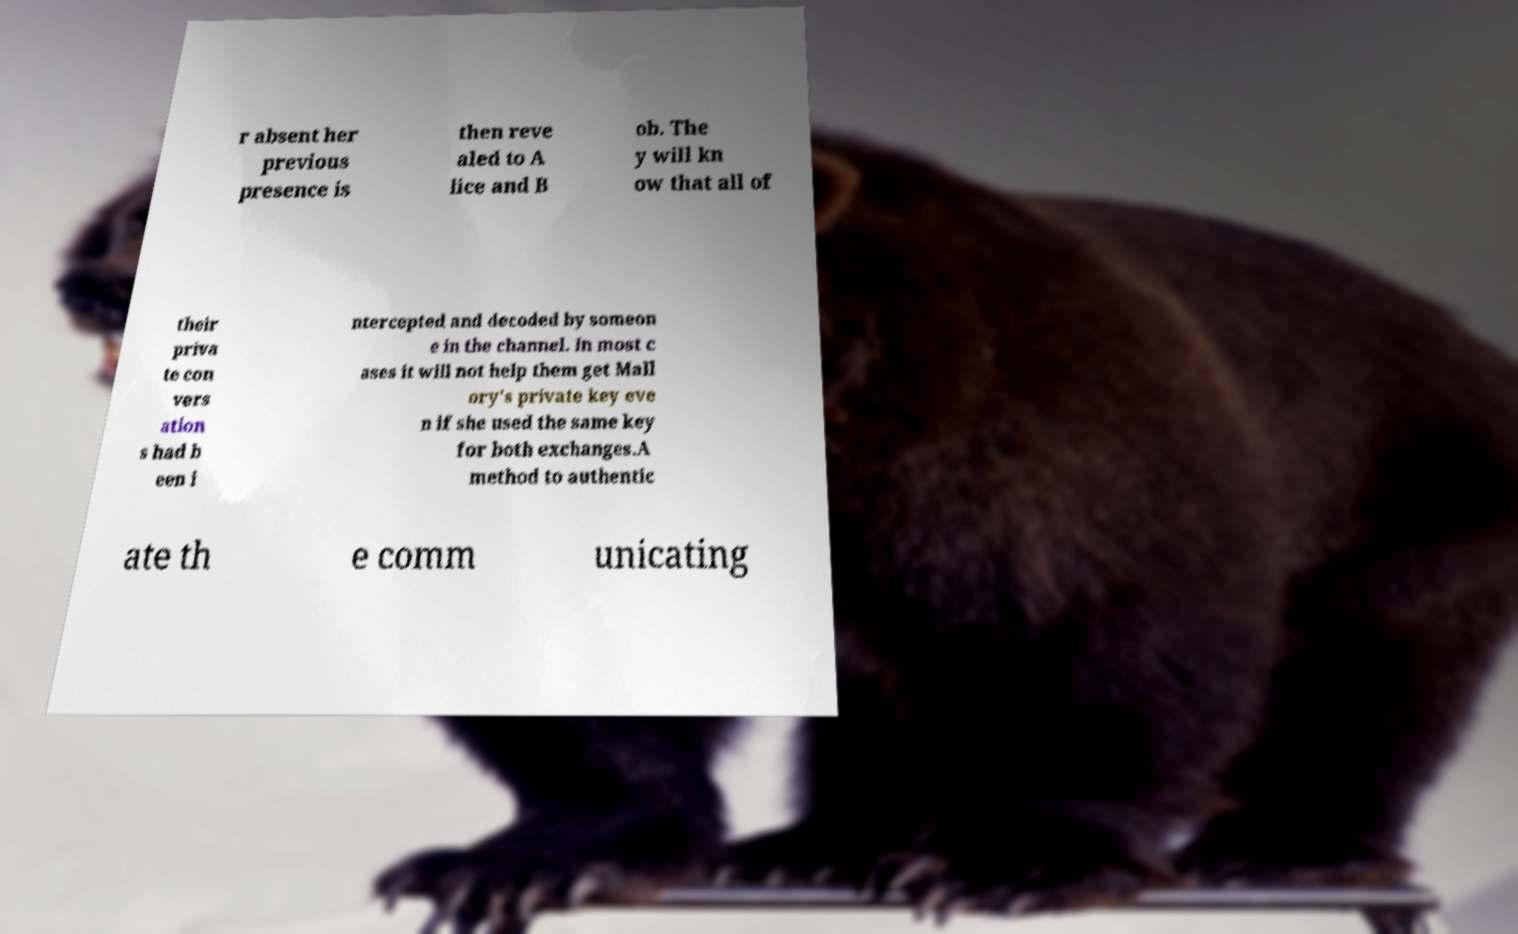Can you read and provide the text displayed in the image?This photo seems to have some interesting text. Can you extract and type it out for me? r absent her previous presence is then reve aled to A lice and B ob. The y will kn ow that all of their priva te con vers ation s had b een i ntercepted and decoded by someon e in the channel. In most c ases it will not help them get Mall ory's private key eve n if she used the same key for both exchanges.A method to authentic ate th e comm unicating 